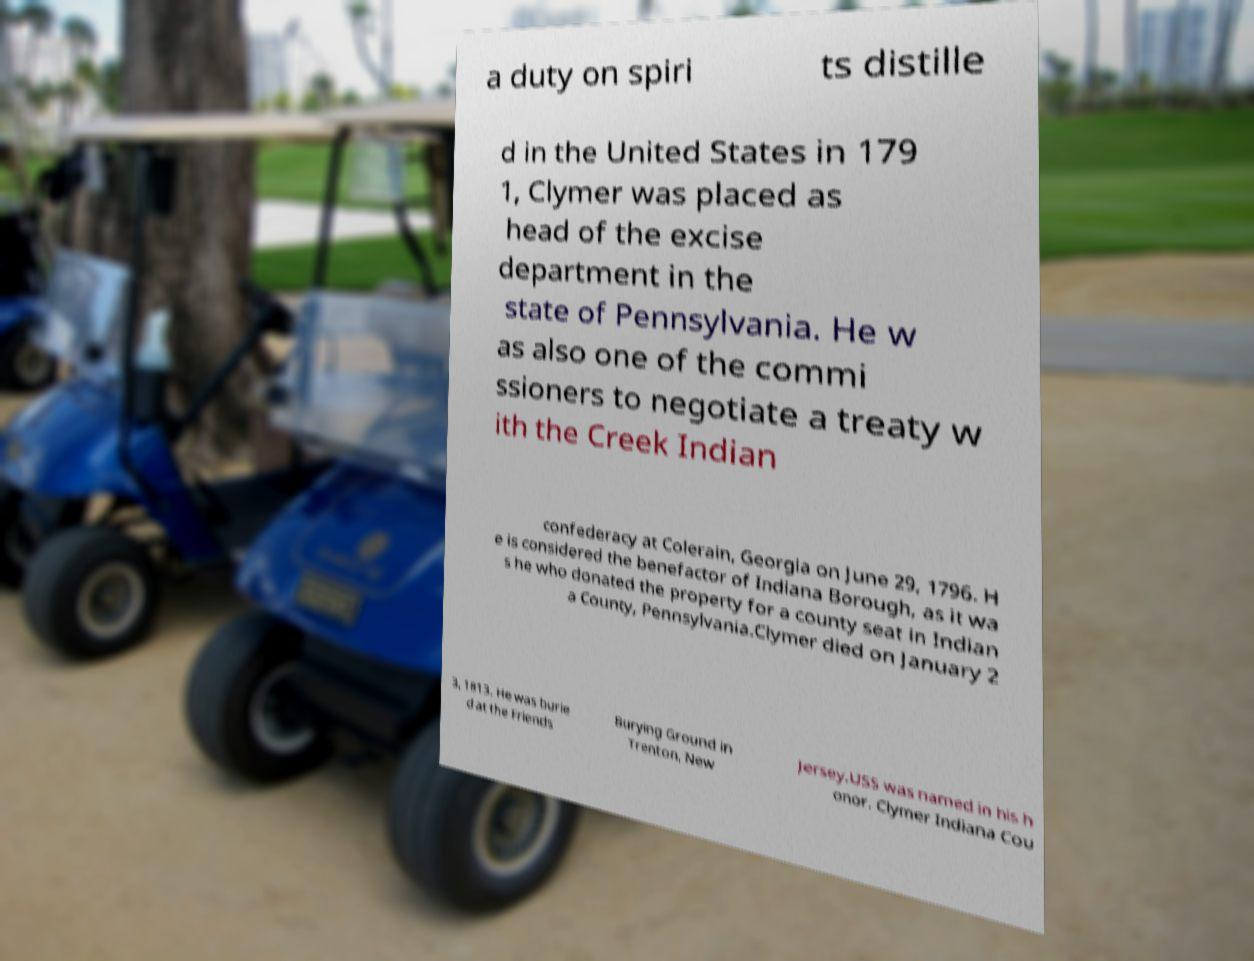There's text embedded in this image that I need extracted. Can you transcribe it verbatim? a duty on spiri ts distille d in the United States in 179 1, Clymer was placed as head of the excise department in the state of Pennsylvania. He w as also one of the commi ssioners to negotiate a treaty w ith the Creek Indian confederacy at Colerain, Georgia on June 29, 1796. H e is considered the benefactor of Indiana Borough, as it wa s he who donated the property for a county seat in Indian a County, Pennsylvania.Clymer died on January 2 3, 1813. He was burie d at the Friends Burying Ground in Trenton, New Jersey.USS was named in his h onor. Clymer Indiana Cou 